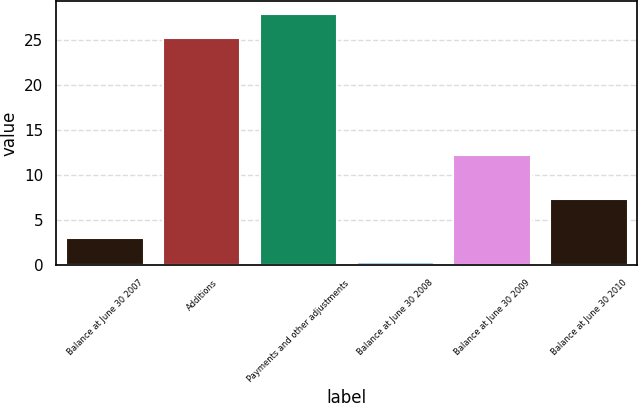<chart> <loc_0><loc_0><loc_500><loc_500><bar_chart><fcel>Balance at June 30 2007<fcel>Additions<fcel>Payments and other adjustments<fcel>Balance at June 30 2008<fcel>Balance at June 30 2009<fcel>Balance at June 30 2010<nl><fcel>3.03<fcel>25.3<fcel>27.93<fcel>0.4<fcel>12.3<fcel>7.4<nl></chart> 